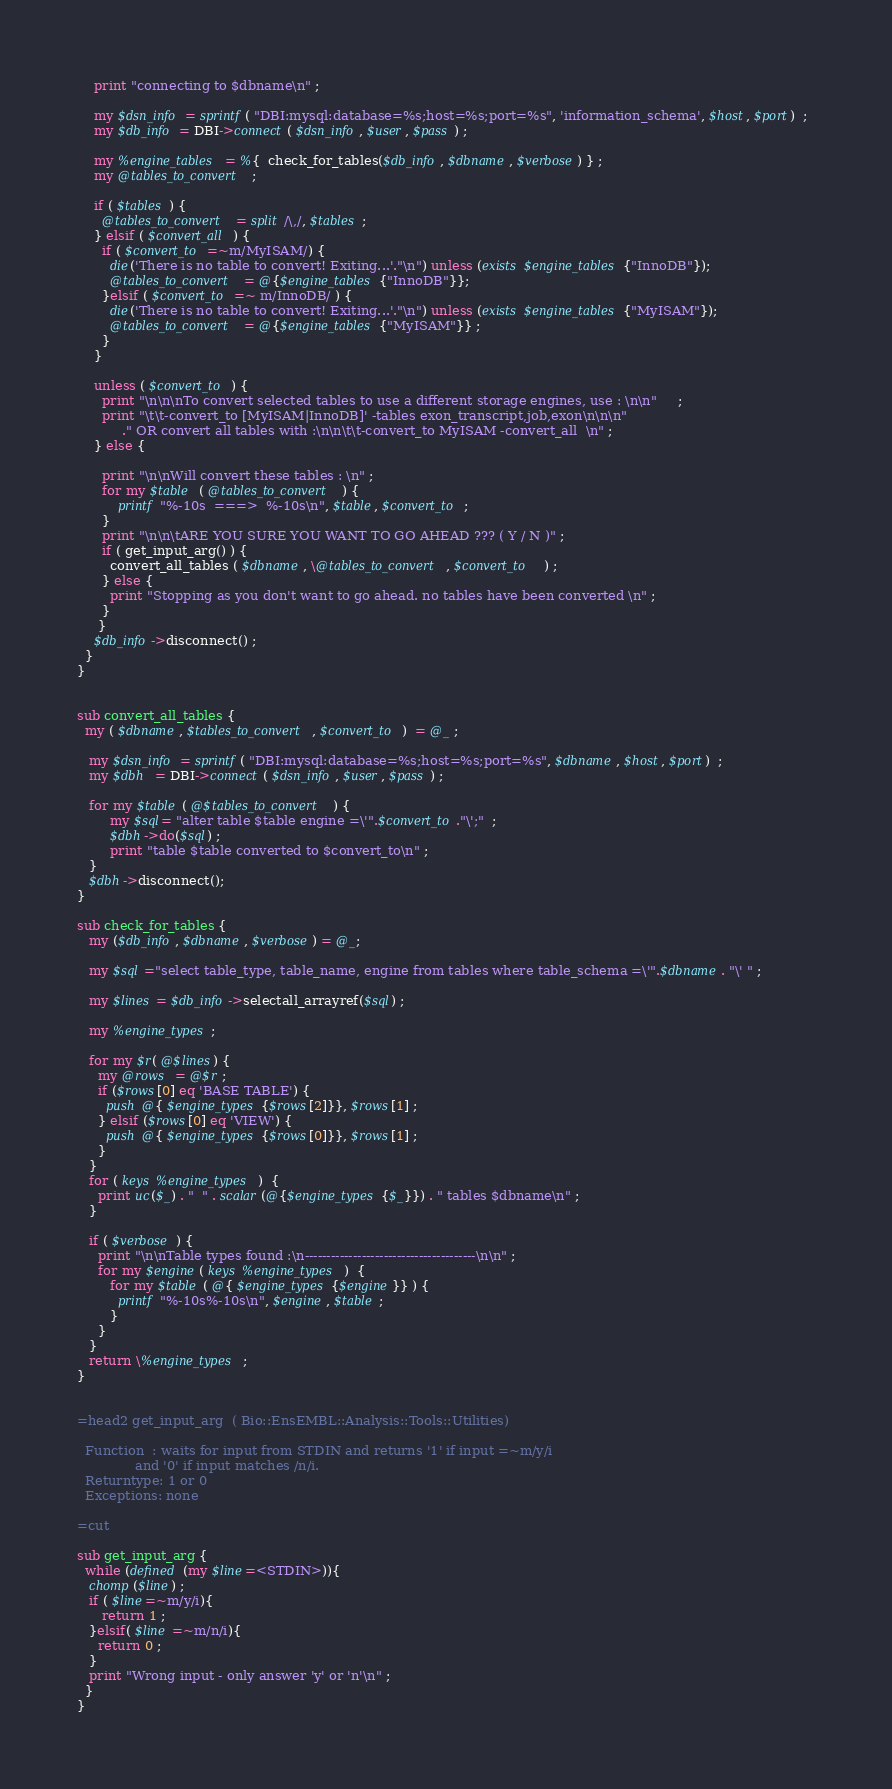Convert code to text. <code><loc_0><loc_0><loc_500><loc_500><_Perl_>    print "connecting to $dbname\n" ; 

    my $dsn_info = sprintf( "DBI:mysql:database=%s;host=%s;port=%s", 'information_schema', $host, $port)  ;  
    my $db_info = DBI->connect( $dsn_info, $user, $pass ) ;   

    my %engine_tables = %{  check_for_tables($db_info, $dbname, $verbose) } ;   
    my @tables_to_convert ;   
      
    if ( $tables ) { 
      @tables_to_convert = split /\,/, $tables ;   
    } elsif ( $convert_all ) { 
      if ( $convert_to =~m/MyISAM/) {    
        die('There is no table to convert! Exiting...'."\n") unless (exists $engine_tables{"InnoDB"}); 
        @tables_to_convert = @{$engine_tables{"InnoDB"}};
      }elsif ( $convert_to =~ m/InnoDB/ ) { 
        die('There is no table to convert! Exiting...'."\n") unless (exists $engine_tables{"MyISAM"}); 
        @tables_to_convert = @{$engine_tables{"MyISAM"}} ;  
      }   
    }
   
    unless ( $convert_to ) {  
      print "\n\n\nTo convert selected tables to use a different storage engines, use : \n\n"     ; 
      print "\t\t-convert_to [MyISAM|InnoDB]' -tables exon_transcript,job,exon\n\n\n"
           ." OR convert all tables with :\n\n\t\t-convert_to MyISAM -convert_all  \n" ;   
    } else {  

      print "\n\nWill convert these tables : \n" ;  
      for my $table  ( @tables_to_convert ) { 
          printf "%-10s  ===>  %-10s\n", $table, $convert_to ;  
      }  
      print "\n\n\tARE YOU SURE YOU WANT TO GO AHEAD ??? ( Y / N )" ; 
      if ( get_input_arg() ) {
        convert_all_tables ( $dbname, \@tables_to_convert, $convert_to   ) ;  
      } else {  
        print "Stopping as you don't want to go ahead. no tables have been converted \n" ; 
      } 
     } 
    $db_info->disconnect() ; 
  }
}  


sub convert_all_tables {   
  my ( $dbname, $tables_to_convert, $convert_to )  = @_ ;   

   my $dsn_info = sprintf( "DBI:mysql:database=%s;host=%s;port=%s", $dbname, $host, $port)  ;  
   my $dbh  = DBI->connect( $dsn_info, $user, $pass ) ;      

   for my $table ( @$tables_to_convert ) { 
        my $sql= "alter table $table engine =\'".$convert_to."\';"  ; 
        $dbh->do($sql) ;  
        print "table $table converted to $convert_to\n" ; 
   }      
   $dbh->disconnect(); 
} 
 
sub check_for_tables { 
   my ($db_info, $dbname, $verbose) = @_;   

   my $sql ="select table_type, table_name, engine from tables where table_schema =\'".$dbname. "\' " ; 

   my $lines = $db_info->selectall_arrayref($sql) ;   

   my %engine_types; 

   for my $r( @$lines) {   
     my @rows  = @$r ; 
     if ($rows[0] eq 'BASE TABLE') {
       push @{ $engine_types{$rows[2]}}, $rows[1] ; 
     } elsif ($rows[0] eq 'VIEW') {
       push @{ $engine_types{$rows[0]}}, $rows[1] ;
     }
   }  
   for ( keys %engine_types )  {  
     print uc($_) . "  " . scalar(@{$engine_types{$_}}) . " tables $dbname\n" ;   
   }  

   if ( $verbose ) {     
     print "\n\nTable types found :\n---------------------------------------\n\n" ; 
     for my $engine( keys %engine_types )  {    
        for my $table ( @{ $engine_types{$engine}} ) {  
          printf "%-10s%-10s\n", $engine, $table ; 
        }  
     }  
   } 
   return \%engine_types ; 
}  


=head2 get_input_arg  ( Bio::EnsEMBL::Analysis::Tools::Utilities) 

  Function  : waits for input from STDIN and returns '1' if input =~m/y/i         
              and '0' if input matches /n/i.  
  Returntype: 1 or 0 
  Exceptions: none

=cut

sub get_input_arg {
  while (defined (my $line=<STDIN>)){
   chomp($line) ;
   if ( $line=~m/y/i){
      return 1 ;
   }elsif( $line =~m/n/i){
     return 0 ;
   }
   print "Wrong input - only answer 'y' or 'n'\n" ;
  }
}


</code> 